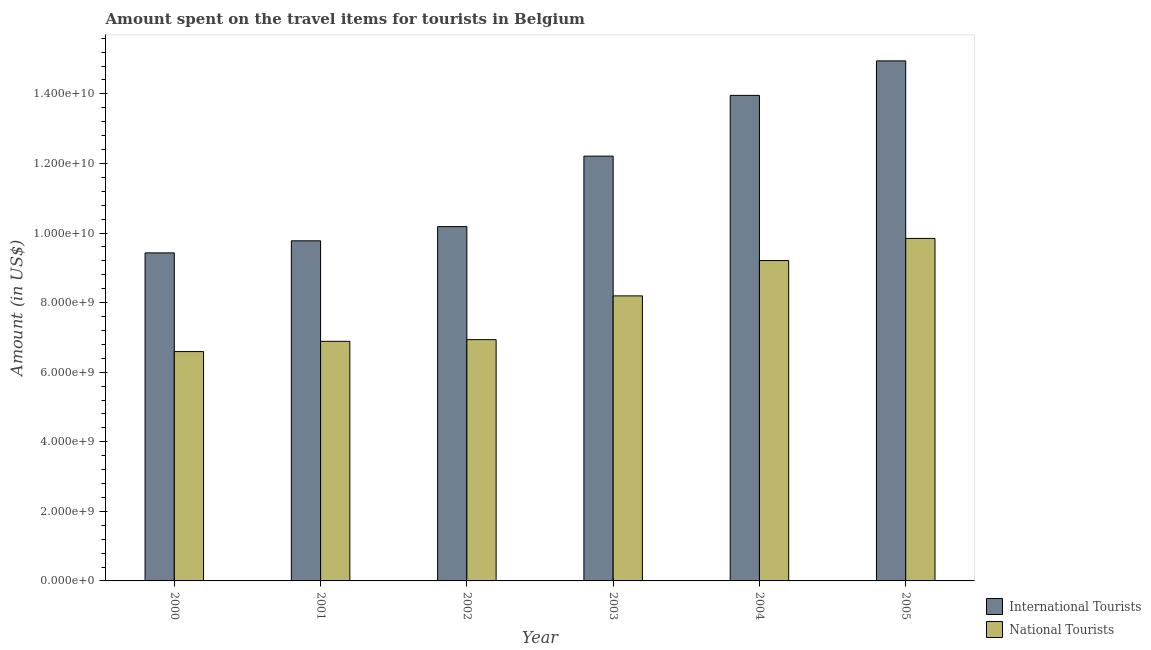How many different coloured bars are there?
Provide a succinct answer. 2. How many groups of bars are there?
Keep it short and to the point. 6. Are the number of bars per tick equal to the number of legend labels?
Give a very brief answer. Yes. Are the number of bars on each tick of the X-axis equal?
Provide a short and direct response. Yes. In how many cases, is the number of bars for a given year not equal to the number of legend labels?
Provide a succinct answer. 0. What is the amount spent on travel items of international tourists in 2000?
Your answer should be very brief. 9.43e+09. Across all years, what is the maximum amount spent on travel items of international tourists?
Offer a very short reply. 1.49e+1. Across all years, what is the minimum amount spent on travel items of national tourists?
Give a very brief answer. 6.59e+09. In which year was the amount spent on travel items of national tourists maximum?
Offer a terse response. 2005. What is the total amount spent on travel items of national tourists in the graph?
Your response must be concise. 4.77e+1. What is the difference between the amount spent on travel items of international tourists in 2001 and that in 2003?
Ensure brevity in your answer.  -2.43e+09. What is the difference between the amount spent on travel items of national tourists in 2004 and the amount spent on travel items of international tourists in 2002?
Make the answer very short. 2.27e+09. What is the average amount spent on travel items of national tourists per year?
Provide a short and direct response. 7.94e+09. In how many years, is the amount spent on travel items of national tourists greater than 6800000000 US$?
Your answer should be compact. 5. What is the ratio of the amount spent on travel items of national tourists in 2000 to that in 2001?
Ensure brevity in your answer.  0.96. Is the amount spent on travel items of national tourists in 2003 less than that in 2004?
Give a very brief answer. Yes. What is the difference between the highest and the second highest amount spent on travel items of national tourists?
Give a very brief answer. 6.37e+08. What is the difference between the highest and the lowest amount spent on travel items of international tourists?
Your response must be concise. 5.52e+09. What does the 2nd bar from the left in 2000 represents?
Keep it short and to the point. National Tourists. What does the 1st bar from the right in 2000 represents?
Your answer should be compact. National Tourists. What is the difference between two consecutive major ticks on the Y-axis?
Your answer should be compact. 2.00e+09. Does the graph contain any zero values?
Your answer should be very brief. No. How many legend labels are there?
Your response must be concise. 2. What is the title of the graph?
Offer a very short reply. Amount spent on the travel items for tourists in Belgium. What is the label or title of the Y-axis?
Offer a very short reply. Amount (in US$). What is the Amount (in US$) of International Tourists in 2000?
Provide a short and direct response. 9.43e+09. What is the Amount (in US$) in National Tourists in 2000?
Give a very brief answer. 6.59e+09. What is the Amount (in US$) in International Tourists in 2001?
Ensure brevity in your answer.  9.78e+09. What is the Amount (in US$) in National Tourists in 2001?
Ensure brevity in your answer.  6.89e+09. What is the Amount (in US$) of International Tourists in 2002?
Offer a terse response. 1.02e+1. What is the Amount (in US$) of National Tourists in 2002?
Your response must be concise. 6.94e+09. What is the Amount (in US$) in International Tourists in 2003?
Your answer should be very brief. 1.22e+1. What is the Amount (in US$) of National Tourists in 2003?
Provide a succinct answer. 8.19e+09. What is the Amount (in US$) in International Tourists in 2004?
Your answer should be compact. 1.40e+1. What is the Amount (in US$) of National Tourists in 2004?
Keep it short and to the point. 9.21e+09. What is the Amount (in US$) in International Tourists in 2005?
Your answer should be very brief. 1.49e+1. What is the Amount (in US$) in National Tourists in 2005?
Ensure brevity in your answer.  9.84e+09. Across all years, what is the maximum Amount (in US$) in International Tourists?
Offer a very short reply. 1.49e+1. Across all years, what is the maximum Amount (in US$) of National Tourists?
Provide a succinct answer. 9.84e+09. Across all years, what is the minimum Amount (in US$) in International Tourists?
Your response must be concise. 9.43e+09. Across all years, what is the minimum Amount (in US$) in National Tourists?
Your answer should be compact. 6.59e+09. What is the total Amount (in US$) of International Tourists in the graph?
Your answer should be very brief. 7.05e+1. What is the total Amount (in US$) in National Tourists in the graph?
Give a very brief answer. 4.77e+1. What is the difference between the Amount (in US$) of International Tourists in 2000 and that in 2001?
Your answer should be compact. -3.47e+08. What is the difference between the Amount (in US$) of National Tourists in 2000 and that in 2001?
Provide a short and direct response. -2.95e+08. What is the difference between the Amount (in US$) in International Tourists in 2000 and that in 2002?
Offer a very short reply. -7.56e+08. What is the difference between the Amount (in US$) in National Tourists in 2000 and that in 2002?
Your answer should be very brief. -3.43e+08. What is the difference between the Amount (in US$) in International Tourists in 2000 and that in 2003?
Ensure brevity in your answer.  -2.78e+09. What is the difference between the Amount (in US$) of National Tourists in 2000 and that in 2003?
Your answer should be very brief. -1.60e+09. What is the difference between the Amount (in US$) in International Tourists in 2000 and that in 2004?
Make the answer very short. -4.53e+09. What is the difference between the Amount (in US$) in National Tourists in 2000 and that in 2004?
Offer a very short reply. -2.62e+09. What is the difference between the Amount (in US$) in International Tourists in 2000 and that in 2005?
Offer a terse response. -5.52e+09. What is the difference between the Amount (in US$) of National Tourists in 2000 and that in 2005?
Give a very brief answer. -3.25e+09. What is the difference between the Amount (in US$) in International Tourists in 2001 and that in 2002?
Give a very brief answer. -4.09e+08. What is the difference between the Amount (in US$) in National Tourists in 2001 and that in 2002?
Offer a terse response. -4.80e+07. What is the difference between the Amount (in US$) of International Tourists in 2001 and that in 2003?
Offer a very short reply. -2.43e+09. What is the difference between the Amount (in US$) of National Tourists in 2001 and that in 2003?
Your answer should be very brief. -1.31e+09. What is the difference between the Amount (in US$) of International Tourists in 2001 and that in 2004?
Your answer should be compact. -4.18e+09. What is the difference between the Amount (in US$) in National Tourists in 2001 and that in 2004?
Provide a short and direct response. -2.32e+09. What is the difference between the Amount (in US$) of International Tourists in 2001 and that in 2005?
Provide a short and direct response. -5.17e+09. What is the difference between the Amount (in US$) of National Tourists in 2001 and that in 2005?
Keep it short and to the point. -2.96e+09. What is the difference between the Amount (in US$) in International Tourists in 2002 and that in 2003?
Offer a terse response. -2.02e+09. What is the difference between the Amount (in US$) in National Tourists in 2002 and that in 2003?
Offer a terse response. -1.26e+09. What is the difference between the Amount (in US$) of International Tourists in 2002 and that in 2004?
Offer a terse response. -3.77e+09. What is the difference between the Amount (in US$) of National Tourists in 2002 and that in 2004?
Offer a very short reply. -2.27e+09. What is the difference between the Amount (in US$) of International Tourists in 2002 and that in 2005?
Offer a terse response. -4.76e+09. What is the difference between the Amount (in US$) in National Tourists in 2002 and that in 2005?
Keep it short and to the point. -2.91e+09. What is the difference between the Amount (in US$) in International Tourists in 2003 and that in 2004?
Your answer should be compact. -1.75e+09. What is the difference between the Amount (in US$) of National Tourists in 2003 and that in 2004?
Your answer should be compact. -1.02e+09. What is the difference between the Amount (in US$) of International Tourists in 2003 and that in 2005?
Make the answer very short. -2.74e+09. What is the difference between the Amount (in US$) in National Tourists in 2003 and that in 2005?
Give a very brief answer. -1.65e+09. What is the difference between the Amount (in US$) of International Tourists in 2004 and that in 2005?
Your answer should be compact. -9.92e+08. What is the difference between the Amount (in US$) in National Tourists in 2004 and that in 2005?
Offer a terse response. -6.37e+08. What is the difference between the Amount (in US$) in International Tourists in 2000 and the Amount (in US$) in National Tourists in 2001?
Your answer should be compact. 2.54e+09. What is the difference between the Amount (in US$) in International Tourists in 2000 and the Amount (in US$) in National Tourists in 2002?
Offer a terse response. 2.49e+09. What is the difference between the Amount (in US$) of International Tourists in 2000 and the Amount (in US$) of National Tourists in 2003?
Your answer should be compact. 1.24e+09. What is the difference between the Amount (in US$) of International Tourists in 2000 and the Amount (in US$) of National Tourists in 2004?
Give a very brief answer. 2.21e+08. What is the difference between the Amount (in US$) of International Tourists in 2000 and the Amount (in US$) of National Tourists in 2005?
Offer a very short reply. -4.16e+08. What is the difference between the Amount (in US$) of International Tourists in 2001 and the Amount (in US$) of National Tourists in 2002?
Your answer should be compact. 2.84e+09. What is the difference between the Amount (in US$) of International Tourists in 2001 and the Amount (in US$) of National Tourists in 2003?
Your answer should be very brief. 1.58e+09. What is the difference between the Amount (in US$) in International Tourists in 2001 and the Amount (in US$) in National Tourists in 2004?
Offer a very short reply. 5.68e+08. What is the difference between the Amount (in US$) of International Tourists in 2001 and the Amount (in US$) of National Tourists in 2005?
Make the answer very short. -6.90e+07. What is the difference between the Amount (in US$) of International Tourists in 2002 and the Amount (in US$) of National Tourists in 2003?
Your answer should be very brief. 1.99e+09. What is the difference between the Amount (in US$) in International Tourists in 2002 and the Amount (in US$) in National Tourists in 2004?
Offer a terse response. 9.77e+08. What is the difference between the Amount (in US$) of International Tourists in 2002 and the Amount (in US$) of National Tourists in 2005?
Ensure brevity in your answer.  3.40e+08. What is the difference between the Amount (in US$) in International Tourists in 2003 and the Amount (in US$) in National Tourists in 2004?
Your answer should be very brief. 3.00e+09. What is the difference between the Amount (in US$) in International Tourists in 2003 and the Amount (in US$) in National Tourists in 2005?
Offer a very short reply. 2.36e+09. What is the difference between the Amount (in US$) in International Tourists in 2004 and the Amount (in US$) in National Tourists in 2005?
Offer a terse response. 4.11e+09. What is the average Amount (in US$) of International Tourists per year?
Offer a very short reply. 1.18e+1. What is the average Amount (in US$) in National Tourists per year?
Your answer should be very brief. 7.94e+09. In the year 2000, what is the difference between the Amount (in US$) of International Tourists and Amount (in US$) of National Tourists?
Provide a succinct answer. 2.84e+09. In the year 2001, what is the difference between the Amount (in US$) of International Tourists and Amount (in US$) of National Tourists?
Give a very brief answer. 2.89e+09. In the year 2002, what is the difference between the Amount (in US$) in International Tourists and Amount (in US$) in National Tourists?
Offer a very short reply. 3.25e+09. In the year 2003, what is the difference between the Amount (in US$) in International Tourists and Amount (in US$) in National Tourists?
Your response must be concise. 4.02e+09. In the year 2004, what is the difference between the Amount (in US$) in International Tourists and Amount (in US$) in National Tourists?
Offer a terse response. 4.75e+09. In the year 2005, what is the difference between the Amount (in US$) of International Tourists and Amount (in US$) of National Tourists?
Keep it short and to the point. 5.10e+09. What is the ratio of the Amount (in US$) of International Tourists in 2000 to that in 2001?
Provide a succinct answer. 0.96. What is the ratio of the Amount (in US$) of National Tourists in 2000 to that in 2001?
Ensure brevity in your answer.  0.96. What is the ratio of the Amount (in US$) in International Tourists in 2000 to that in 2002?
Provide a short and direct response. 0.93. What is the ratio of the Amount (in US$) in National Tourists in 2000 to that in 2002?
Offer a terse response. 0.95. What is the ratio of the Amount (in US$) in International Tourists in 2000 to that in 2003?
Your answer should be compact. 0.77. What is the ratio of the Amount (in US$) of National Tourists in 2000 to that in 2003?
Offer a terse response. 0.8. What is the ratio of the Amount (in US$) in International Tourists in 2000 to that in 2004?
Provide a succinct answer. 0.68. What is the ratio of the Amount (in US$) in National Tourists in 2000 to that in 2004?
Keep it short and to the point. 0.72. What is the ratio of the Amount (in US$) of International Tourists in 2000 to that in 2005?
Keep it short and to the point. 0.63. What is the ratio of the Amount (in US$) in National Tourists in 2000 to that in 2005?
Keep it short and to the point. 0.67. What is the ratio of the Amount (in US$) in International Tourists in 2001 to that in 2002?
Your answer should be very brief. 0.96. What is the ratio of the Amount (in US$) of National Tourists in 2001 to that in 2002?
Make the answer very short. 0.99. What is the ratio of the Amount (in US$) of International Tourists in 2001 to that in 2003?
Your response must be concise. 0.8. What is the ratio of the Amount (in US$) in National Tourists in 2001 to that in 2003?
Make the answer very short. 0.84. What is the ratio of the Amount (in US$) of International Tourists in 2001 to that in 2004?
Make the answer very short. 0.7. What is the ratio of the Amount (in US$) of National Tourists in 2001 to that in 2004?
Your answer should be very brief. 0.75. What is the ratio of the Amount (in US$) of International Tourists in 2001 to that in 2005?
Provide a short and direct response. 0.65. What is the ratio of the Amount (in US$) of National Tourists in 2001 to that in 2005?
Ensure brevity in your answer.  0.7. What is the ratio of the Amount (in US$) in International Tourists in 2002 to that in 2003?
Provide a short and direct response. 0.83. What is the ratio of the Amount (in US$) in National Tourists in 2002 to that in 2003?
Make the answer very short. 0.85. What is the ratio of the Amount (in US$) of International Tourists in 2002 to that in 2004?
Your answer should be compact. 0.73. What is the ratio of the Amount (in US$) in National Tourists in 2002 to that in 2004?
Make the answer very short. 0.75. What is the ratio of the Amount (in US$) in International Tourists in 2002 to that in 2005?
Give a very brief answer. 0.68. What is the ratio of the Amount (in US$) in National Tourists in 2002 to that in 2005?
Give a very brief answer. 0.7. What is the ratio of the Amount (in US$) of International Tourists in 2003 to that in 2004?
Your answer should be compact. 0.87. What is the ratio of the Amount (in US$) of National Tourists in 2003 to that in 2004?
Offer a very short reply. 0.89. What is the ratio of the Amount (in US$) in International Tourists in 2003 to that in 2005?
Offer a very short reply. 0.82. What is the ratio of the Amount (in US$) in National Tourists in 2003 to that in 2005?
Make the answer very short. 0.83. What is the ratio of the Amount (in US$) of International Tourists in 2004 to that in 2005?
Make the answer very short. 0.93. What is the ratio of the Amount (in US$) in National Tourists in 2004 to that in 2005?
Give a very brief answer. 0.94. What is the difference between the highest and the second highest Amount (in US$) of International Tourists?
Keep it short and to the point. 9.92e+08. What is the difference between the highest and the second highest Amount (in US$) in National Tourists?
Provide a short and direct response. 6.37e+08. What is the difference between the highest and the lowest Amount (in US$) in International Tourists?
Your answer should be very brief. 5.52e+09. What is the difference between the highest and the lowest Amount (in US$) in National Tourists?
Ensure brevity in your answer.  3.25e+09. 